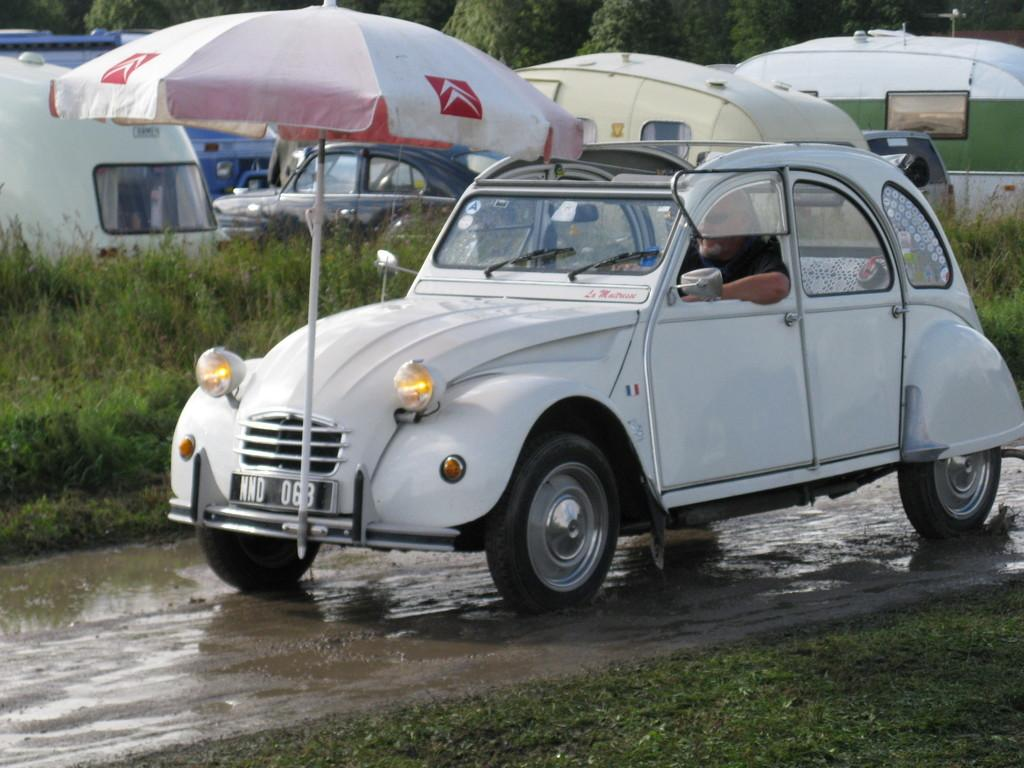What is located in the foreground of the image? There is a car and an umbrella in the foreground of the image. What can be seen in the background of the image? There are vehicles and trees in the background of the image. What is present at the bottom of the image? There is a walkway and grass at the bottom of the image. What type of humor can be seen in the image? There is no humor present in the image; it features a car, an umbrella, vehicles, trees, a walkway, and grass. Is there a scarecrow visible in the image? No, there is no scarecrow present in the image. 